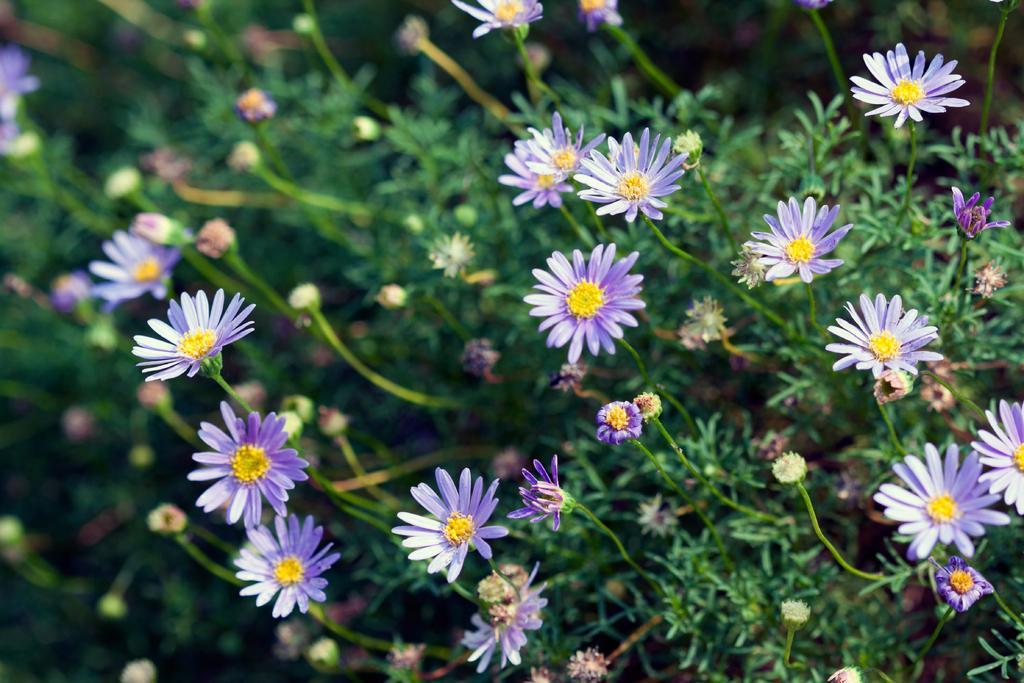How would you summarize this image in a sentence or two? There are many violet and yellow color flowers in the plants. 